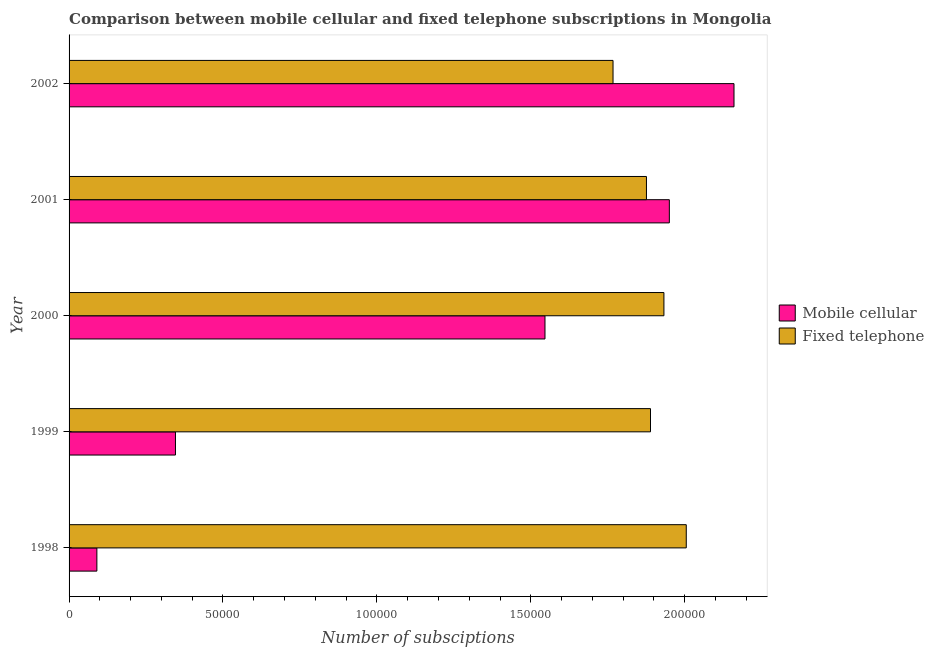How many different coloured bars are there?
Give a very brief answer. 2. Are the number of bars per tick equal to the number of legend labels?
Your answer should be compact. Yes. Are the number of bars on each tick of the Y-axis equal?
Give a very brief answer. Yes. How many bars are there on the 2nd tick from the bottom?
Offer a very short reply. 2. What is the label of the 5th group of bars from the top?
Make the answer very short. 1998. In how many cases, is the number of bars for a given year not equal to the number of legend labels?
Keep it short and to the point. 0. What is the number of mobile cellular subscriptions in 2002?
Your response must be concise. 2.16e+05. Across all years, what is the maximum number of mobile cellular subscriptions?
Offer a very short reply. 2.16e+05. Across all years, what is the minimum number of fixed telephone subscriptions?
Provide a succinct answer. 1.77e+05. What is the total number of fixed telephone subscriptions in the graph?
Provide a succinct answer. 9.47e+05. What is the difference between the number of mobile cellular subscriptions in 1998 and that in 2001?
Provide a succinct answer. -1.86e+05. What is the difference between the number of fixed telephone subscriptions in 1998 and the number of mobile cellular subscriptions in 2001?
Offer a very short reply. 5494. What is the average number of mobile cellular subscriptions per year?
Your answer should be very brief. 1.22e+05. In the year 2000, what is the difference between the number of mobile cellular subscriptions and number of fixed telephone subscriptions?
Ensure brevity in your answer.  -3.86e+04. What is the ratio of the number of mobile cellular subscriptions in 2000 to that in 2001?
Keep it short and to the point. 0.79. Is the number of fixed telephone subscriptions in 2001 less than that in 2002?
Make the answer very short. No. Is the difference between the number of mobile cellular subscriptions in 1998 and 1999 greater than the difference between the number of fixed telephone subscriptions in 1998 and 1999?
Ensure brevity in your answer.  No. What is the difference between the highest and the second highest number of fixed telephone subscriptions?
Give a very brief answer. 7255. What is the difference between the highest and the lowest number of fixed telephone subscriptions?
Offer a very short reply. 2.38e+04. In how many years, is the number of mobile cellular subscriptions greater than the average number of mobile cellular subscriptions taken over all years?
Offer a very short reply. 3. Is the sum of the number of fixed telephone subscriptions in 1999 and 2000 greater than the maximum number of mobile cellular subscriptions across all years?
Keep it short and to the point. Yes. What does the 2nd bar from the top in 2000 represents?
Provide a short and direct response. Mobile cellular. What does the 1st bar from the bottom in 1999 represents?
Give a very brief answer. Mobile cellular. Are all the bars in the graph horizontal?
Offer a very short reply. Yes. What is the difference between two consecutive major ticks on the X-axis?
Make the answer very short. 5.00e+04. Does the graph contain any zero values?
Offer a very short reply. No. How are the legend labels stacked?
Provide a short and direct response. Vertical. What is the title of the graph?
Your response must be concise. Comparison between mobile cellular and fixed telephone subscriptions in Mongolia. Does "Taxes on exports" appear as one of the legend labels in the graph?
Your answer should be compact. No. What is the label or title of the X-axis?
Offer a very short reply. Number of subsciptions. What is the label or title of the Y-axis?
Your answer should be compact. Year. What is the Number of subsciptions of Mobile cellular in 1998?
Offer a very short reply. 9032. What is the Number of subsciptions in Fixed telephone in 1998?
Ensure brevity in your answer.  2.00e+05. What is the Number of subsciptions in Mobile cellular in 1999?
Your answer should be compact. 3.46e+04. What is the Number of subsciptions in Fixed telephone in 1999?
Offer a terse response. 1.89e+05. What is the Number of subsciptions in Mobile cellular in 2000?
Offer a terse response. 1.55e+05. What is the Number of subsciptions of Fixed telephone in 2000?
Your answer should be very brief. 1.93e+05. What is the Number of subsciptions of Mobile cellular in 2001?
Ensure brevity in your answer.  1.95e+05. What is the Number of subsciptions of Fixed telephone in 2001?
Make the answer very short. 1.88e+05. What is the Number of subsciptions of Mobile cellular in 2002?
Ensure brevity in your answer.  2.16e+05. What is the Number of subsciptions in Fixed telephone in 2002?
Make the answer very short. 1.77e+05. Across all years, what is the maximum Number of subsciptions in Mobile cellular?
Give a very brief answer. 2.16e+05. Across all years, what is the maximum Number of subsciptions of Fixed telephone?
Make the answer very short. 2.00e+05. Across all years, what is the minimum Number of subsciptions in Mobile cellular?
Your response must be concise. 9032. Across all years, what is the minimum Number of subsciptions in Fixed telephone?
Keep it short and to the point. 1.77e+05. What is the total Number of subsciptions of Mobile cellular in the graph?
Keep it short and to the point. 6.09e+05. What is the total Number of subsciptions in Fixed telephone in the graph?
Ensure brevity in your answer.  9.47e+05. What is the difference between the Number of subsciptions of Mobile cellular in 1998 and that in 1999?
Your answer should be compact. -2.55e+04. What is the difference between the Number of subsciptions of Fixed telephone in 1998 and that in 1999?
Your answer should be compact. 1.16e+04. What is the difference between the Number of subsciptions in Mobile cellular in 1998 and that in 2000?
Offer a very short reply. -1.46e+05. What is the difference between the Number of subsciptions in Fixed telephone in 1998 and that in 2000?
Make the answer very short. 7255. What is the difference between the Number of subsciptions in Mobile cellular in 1998 and that in 2001?
Your response must be concise. -1.86e+05. What is the difference between the Number of subsciptions of Fixed telephone in 1998 and that in 2001?
Offer a terse response. 1.29e+04. What is the difference between the Number of subsciptions of Mobile cellular in 1998 and that in 2002?
Give a very brief answer. -2.07e+05. What is the difference between the Number of subsciptions in Fixed telephone in 1998 and that in 2002?
Offer a terse response. 2.38e+04. What is the difference between the Number of subsciptions of Mobile cellular in 1999 and that in 2000?
Your response must be concise. -1.20e+05. What is the difference between the Number of subsciptions in Fixed telephone in 1999 and that in 2000?
Your answer should be very brief. -4364. What is the difference between the Number of subsciptions of Mobile cellular in 1999 and that in 2001?
Offer a terse response. -1.60e+05. What is the difference between the Number of subsciptions in Fixed telephone in 1999 and that in 2001?
Provide a short and direct response. 1314. What is the difference between the Number of subsciptions of Mobile cellular in 1999 and that in 2002?
Ensure brevity in your answer.  -1.81e+05. What is the difference between the Number of subsciptions of Fixed telephone in 1999 and that in 2002?
Make the answer very short. 1.22e+04. What is the difference between the Number of subsciptions in Mobile cellular in 2000 and that in 2001?
Give a very brief answer. -4.04e+04. What is the difference between the Number of subsciptions in Fixed telephone in 2000 and that in 2001?
Provide a short and direct response. 5678. What is the difference between the Number of subsciptions in Mobile cellular in 2000 and that in 2002?
Provide a succinct answer. -6.14e+04. What is the difference between the Number of subsciptions of Fixed telephone in 2000 and that in 2002?
Provide a succinct answer. 1.65e+04. What is the difference between the Number of subsciptions in Mobile cellular in 2001 and that in 2002?
Give a very brief answer. -2.10e+04. What is the difference between the Number of subsciptions in Fixed telephone in 2001 and that in 2002?
Your answer should be very brief. 1.09e+04. What is the difference between the Number of subsciptions in Mobile cellular in 1998 and the Number of subsciptions in Fixed telephone in 1999?
Keep it short and to the point. -1.80e+05. What is the difference between the Number of subsciptions of Mobile cellular in 1998 and the Number of subsciptions of Fixed telephone in 2000?
Your answer should be compact. -1.84e+05. What is the difference between the Number of subsciptions in Mobile cellular in 1998 and the Number of subsciptions in Fixed telephone in 2001?
Offer a very short reply. -1.79e+05. What is the difference between the Number of subsciptions in Mobile cellular in 1998 and the Number of subsciptions in Fixed telephone in 2002?
Your response must be concise. -1.68e+05. What is the difference between the Number of subsciptions in Mobile cellular in 1999 and the Number of subsciptions in Fixed telephone in 2000?
Provide a short and direct response. -1.59e+05. What is the difference between the Number of subsciptions of Mobile cellular in 1999 and the Number of subsciptions of Fixed telephone in 2001?
Offer a terse response. -1.53e+05. What is the difference between the Number of subsciptions in Mobile cellular in 1999 and the Number of subsciptions in Fixed telephone in 2002?
Your response must be concise. -1.42e+05. What is the difference between the Number of subsciptions in Mobile cellular in 2000 and the Number of subsciptions in Fixed telephone in 2001?
Offer a very short reply. -3.30e+04. What is the difference between the Number of subsciptions in Mobile cellular in 2000 and the Number of subsciptions in Fixed telephone in 2002?
Offer a very short reply. -2.21e+04. What is the difference between the Number of subsciptions in Mobile cellular in 2001 and the Number of subsciptions in Fixed telephone in 2002?
Your response must be concise. 1.83e+04. What is the average Number of subsciptions of Mobile cellular per year?
Provide a short and direct response. 1.22e+05. What is the average Number of subsciptions of Fixed telephone per year?
Keep it short and to the point. 1.89e+05. In the year 1998, what is the difference between the Number of subsciptions of Mobile cellular and Number of subsciptions of Fixed telephone?
Offer a terse response. -1.91e+05. In the year 1999, what is the difference between the Number of subsciptions of Mobile cellular and Number of subsciptions of Fixed telephone?
Provide a short and direct response. -1.54e+05. In the year 2000, what is the difference between the Number of subsciptions in Mobile cellular and Number of subsciptions in Fixed telephone?
Keep it short and to the point. -3.86e+04. In the year 2001, what is the difference between the Number of subsciptions in Mobile cellular and Number of subsciptions in Fixed telephone?
Your answer should be compact. 7439. In the year 2002, what is the difference between the Number of subsciptions of Mobile cellular and Number of subsciptions of Fixed telephone?
Provide a short and direct response. 3.93e+04. What is the ratio of the Number of subsciptions in Mobile cellular in 1998 to that in 1999?
Offer a very short reply. 0.26. What is the ratio of the Number of subsciptions of Fixed telephone in 1998 to that in 1999?
Provide a succinct answer. 1.06. What is the ratio of the Number of subsciptions in Mobile cellular in 1998 to that in 2000?
Your response must be concise. 0.06. What is the ratio of the Number of subsciptions in Fixed telephone in 1998 to that in 2000?
Offer a very short reply. 1.04. What is the ratio of the Number of subsciptions of Mobile cellular in 1998 to that in 2001?
Give a very brief answer. 0.05. What is the ratio of the Number of subsciptions of Fixed telephone in 1998 to that in 2001?
Keep it short and to the point. 1.07. What is the ratio of the Number of subsciptions of Mobile cellular in 1998 to that in 2002?
Your answer should be compact. 0.04. What is the ratio of the Number of subsciptions of Fixed telephone in 1998 to that in 2002?
Keep it short and to the point. 1.13. What is the ratio of the Number of subsciptions of Mobile cellular in 1999 to that in 2000?
Provide a succinct answer. 0.22. What is the ratio of the Number of subsciptions of Fixed telephone in 1999 to that in 2000?
Ensure brevity in your answer.  0.98. What is the ratio of the Number of subsciptions in Mobile cellular in 1999 to that in 2001?
Your answer should be very brief. 0.18. What is the ratio of the Number of subsciptions of Mobile cellular in 1999 to that in 2002?
Your answer should be very brief. 0.16. What is the ratio of the Number of subsciptions in Fixed telephone in 1999 to that in 2002?
Give a very brief answer. 1.07. What is the ratio of the Number of subsciptions of Mobile cellular in 2000 to that in 2001?
Offer a terse response. 0.79. What is the ratio of the Number of subsciptions in Fixed telephone in 2000 to that in 2001?
Keep it short and to the point. 1.03. What is the ratio of the Number of subsciptions of Mobile cellular in 2000 to that in 2002?
Provide a short and direct response. 0.72. What is the ratio of the Number of subsciptions of Fixed telephone in 2000 to that in 2002?
Ensure brevity in your answer.  1.09. What is the ratio of the Number of subsciptions of Mobile cellular in 2001 to that in 2002?
Ensure brevity in your answer.  0.9. What is the ratio of the Number of subsciptions in Fixed telephone in 2001 to that in 2002?
Ensure brevity in your answer.  1.06. What is the difference between the highest and the second highest Number of subsciptions of Mobile cellular?
Give a very brief answer. 2.10e+04. What is the difference between the highest and the second highest Number of subsciptions in Fixed telephone?
Your response must be concise. 7255. What is the difference between the highest and the lowest Number of subsciptions of Mobile cellular?
Your response must be concise. 2.07e+05. What is the difference between the highest and the lowest Number of subsciptions of Fixed telephone?
Your answer should be very brief. 2.38e+04. 